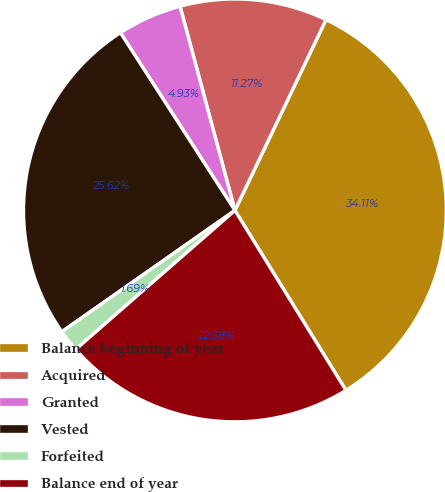Convert chart. <chart><loc_0><loc_0><loc_500><loc_500><pie_chart><fcel>Balance beginning of year<fcel>Acquired<fcel>Granted<fcel>Vested<fcel>Forfeited<fcel>Balance end of year<nl><fcel>34.11%<fcel>11.27%<fcel>4.93%<fcel>25.62%<fcel>1.69%<fcel>22.38%<nl></chart> 